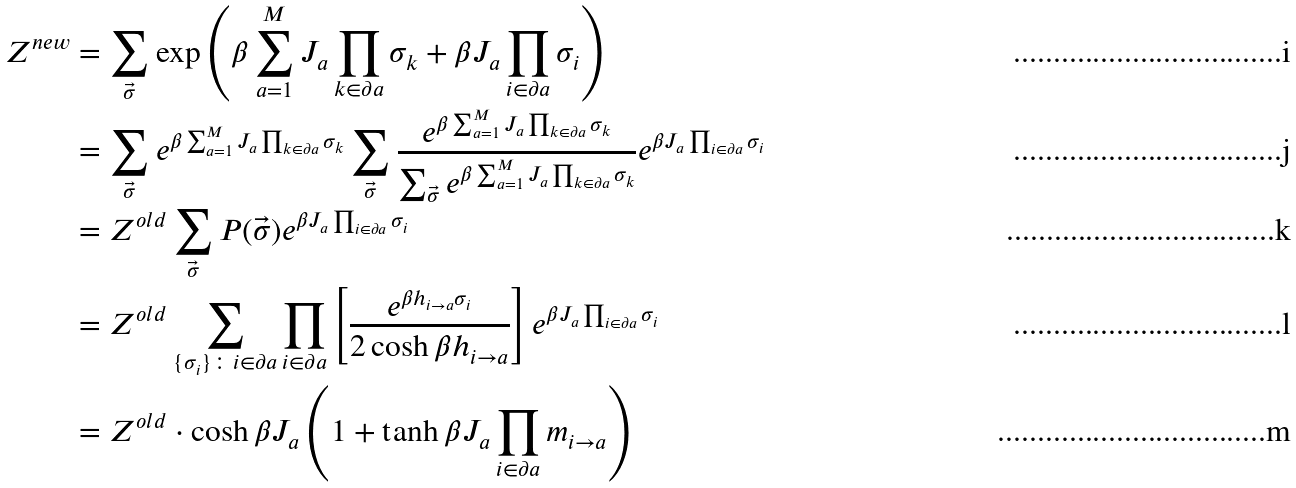Convert formula to latex. <formula><loc_0><loc_0><loc_500><loc_500>Z ^ { n e w } & = \sum _ { \vec { \sigma } } \exp \left ( { \beta \sum _ { a = 1 } ^ { M } J _ { a } \prod _ { k \in \partial a } \sigma _ { k } + \beta J _ { a } \prod _ { i \in \partial a } \sigma _ { i } } \right ) \\ & = \sum _ { \vec { \sigma } } e ^ { \beta \sum _ { a = 1 } ^ { M } J _ { a } \prod _ { k \in \partial a } \sigma _ { k } } \sum _ { \vec { \sigma } } \frac { e ^ { \beta \sum _ { a = 1 } ^ { M } J _ { a } \prod _ { k \in \partial a } \sigma _ { k } } } { \sum _ { \vec { \sigma } } e ^ { \beta \sum _ { a = 1 } ^ { M } J _ { a } \prod _ { k \in \partial a } \sigma _ { k } } } e ^ { \beta J _ { a } \prod _ { i \in \partial a } \sigma _ { i } } \\ & = Z ^ { o l d } \sum _ { \vec { \sigma } } P ( \vec { \sigma } ) e ^ { \beta J _ { a } \prod _ { i \in \partial a } \sigma _ { i } } \\ & = Z ^ { o l d } \sum _ { \{ \sigma _ { i } \} \colon i \in \partial a } \prod _ { i \in \partial a } \left [ \frac { e ^ { \beta h _ { i \rightarrow a } \sigma _ { i } } } { 2 \cosh \beta h _ { i \rightarrow a } } \right ] e ^ { \beta J _ { a } \prod _ { i \in \partial a } \sigma _ { i } } \\ & = Z ^ { o l d } \cdot \cosh \beta J _ { a } \left ( 1 + \tanh \beta J _ { a } \prod _ { i \in \partial a } m _ { i \rightarrow a } \right )</formula> 